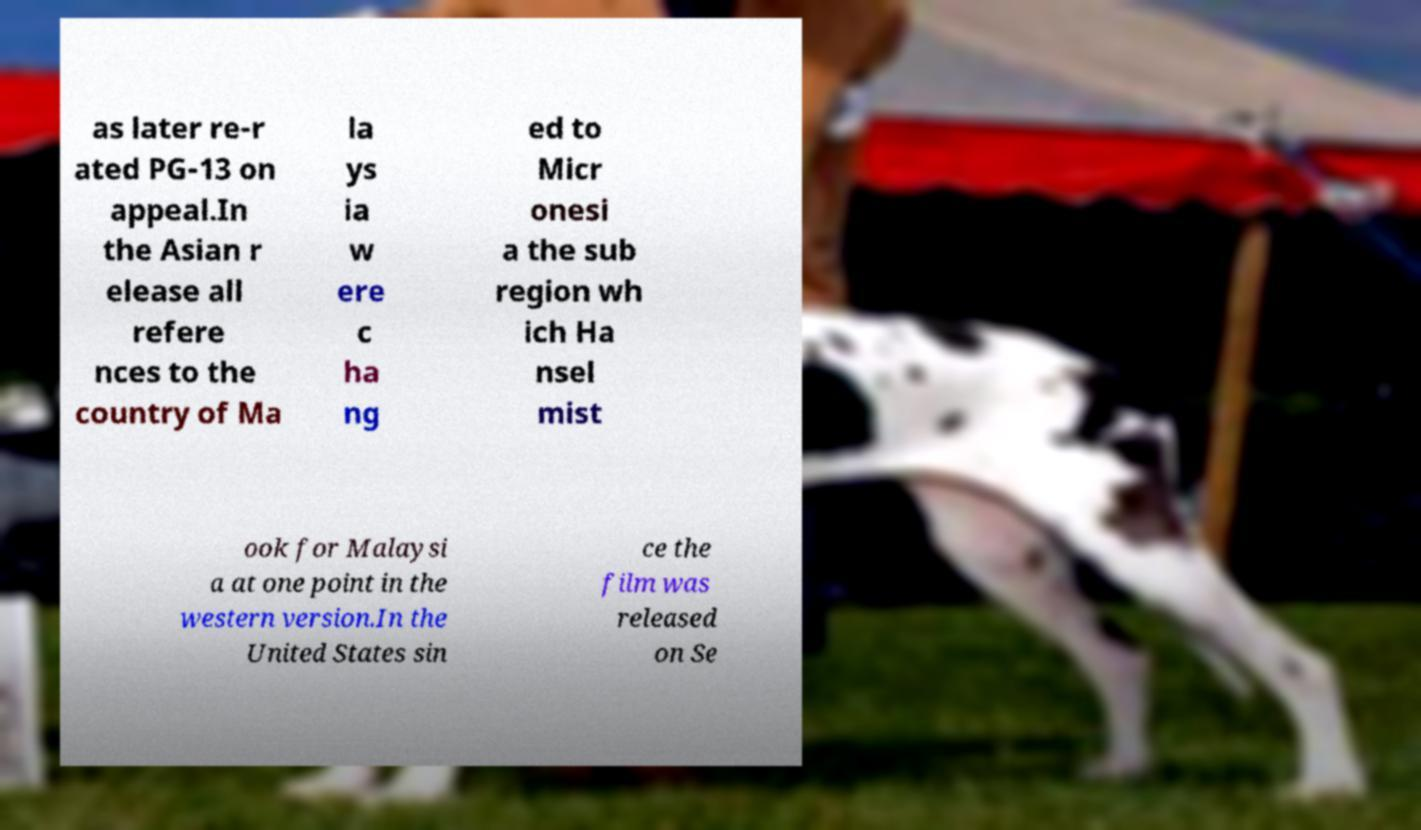Could you extract and type out the text from this image? as later re-r ated PG-13 on appeal.In the Asian r elease all refere nces to the country of Ma la ys ia w ere c ha ng ed to Micr onesi a the sub region wh ich Ha nsel mist ook for Malaysi a at one point in the western version.In the United States sin ce the film was released on Se 